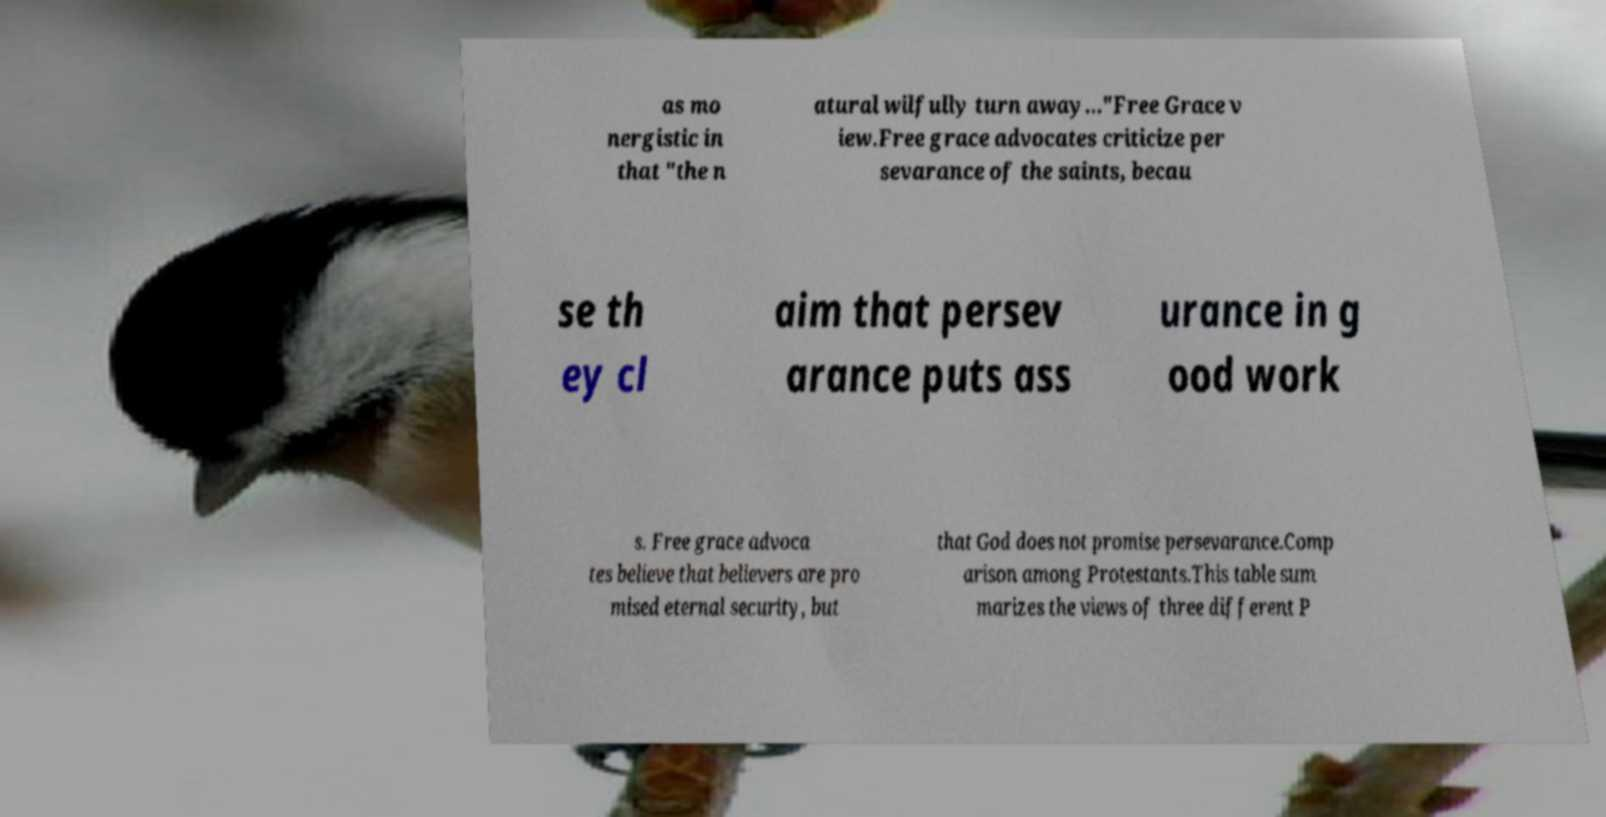For documentation purposes, I need the text within this image transcribed. Could you provide that? as mo nergistic in that "the n atural wilfully turn away…"Free Grace v iew.Free grace advocates criticize per sevarance of the saints, becau se th ey cl aim that persev arance puts ass urance in g ood work s. Free grace advoca tes believe that believers are pro mised eternal security, but that God does not promise persevarance.Comp arison among Protestants.This table sum marizes the views of three different P 